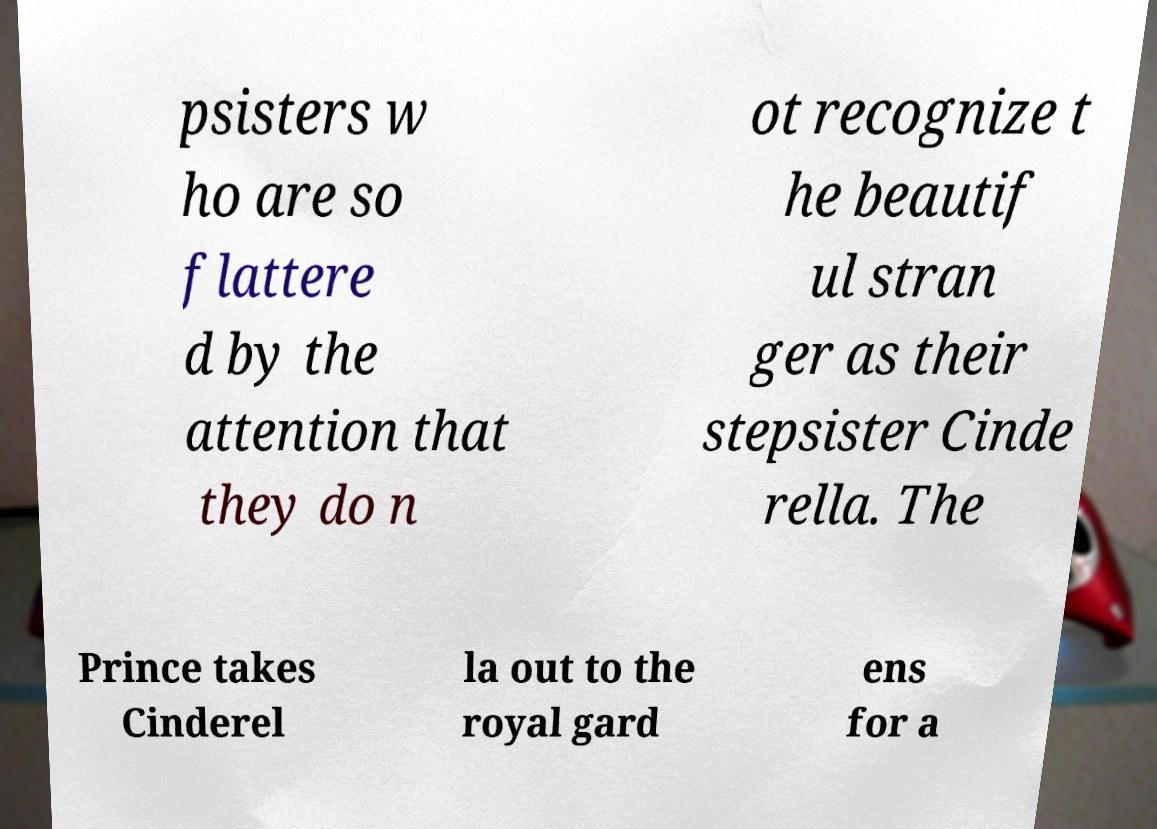There's text embedded in this image that I need extracted. Can you transcribe it verbatim? psisters w ho are so flattere d by the attention that they do n ot recognize t he beautif ul stran ger as their stepsister Cinde rella. The Prince takes Cinderel la out to the royal gard ens for a 